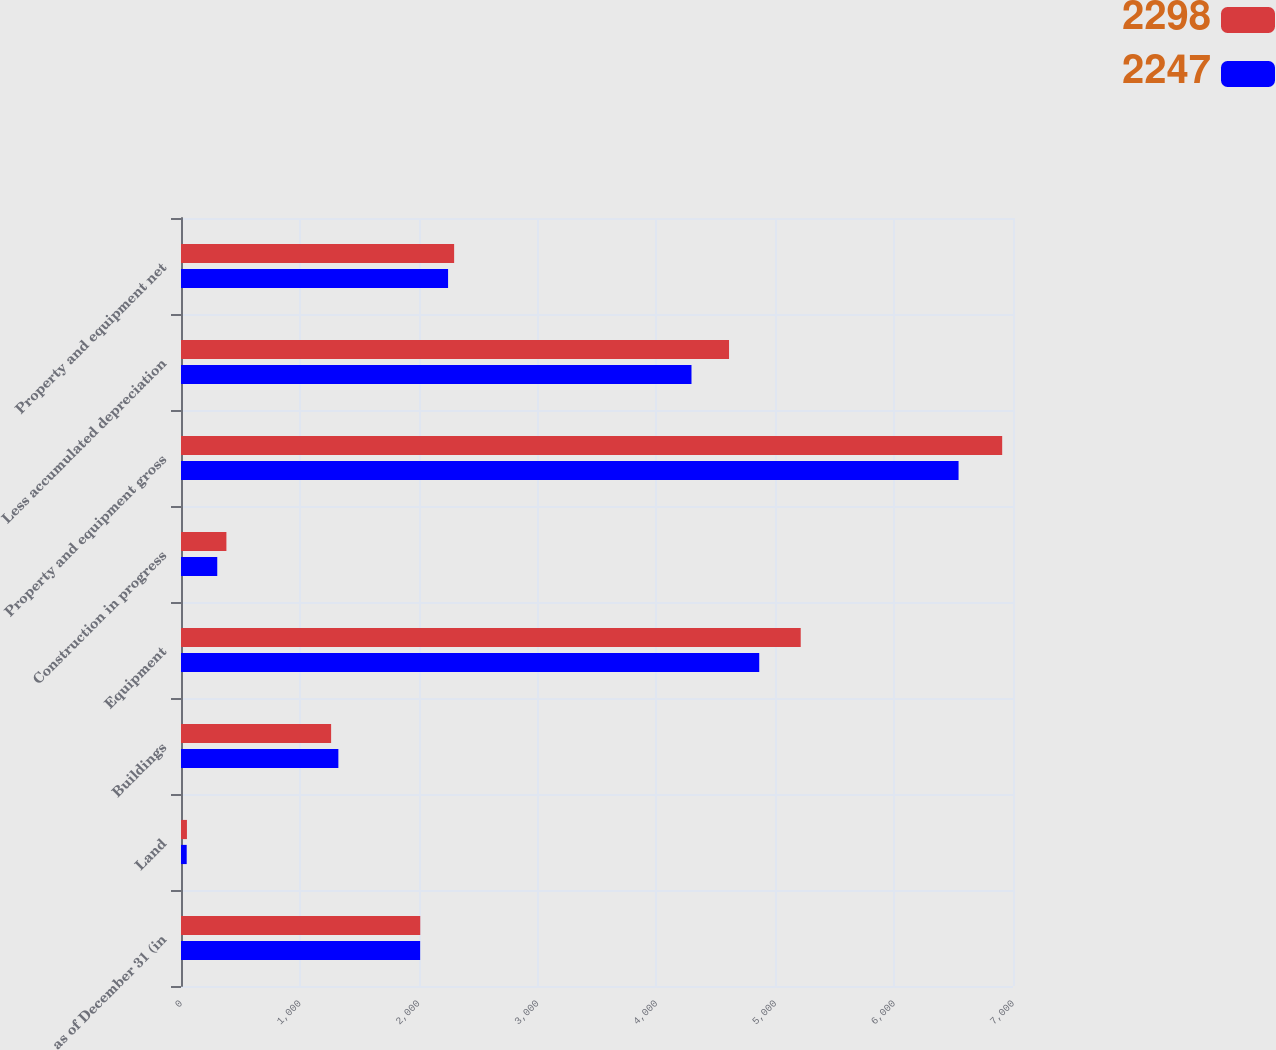Convert chart to OTSL. <chart><loc_0><loc_0><loc_500><loc_500><stacked_bar_chart><ecel><fcel>as of December 31 (in<fcel>Land<fcel>Buildings<fcel>Equipment<fcel>Construction in progress<fcel>Property and equipment gross<fcel>Less accumulated depreciation<fcel>Property and equipment net<nl><fcel>2298<fcel>2013<fcel>50<fcel>1263<fcel>5214<fcel>382<fcel>6909<fcel>4611<fcel>2298<nl><fcel>2247<fcel>2012<fcel>48<fcel>1324<fcel>4865<fcel>305<fcel>6542<fcel>4295<fcel>2247<nl></chart> 